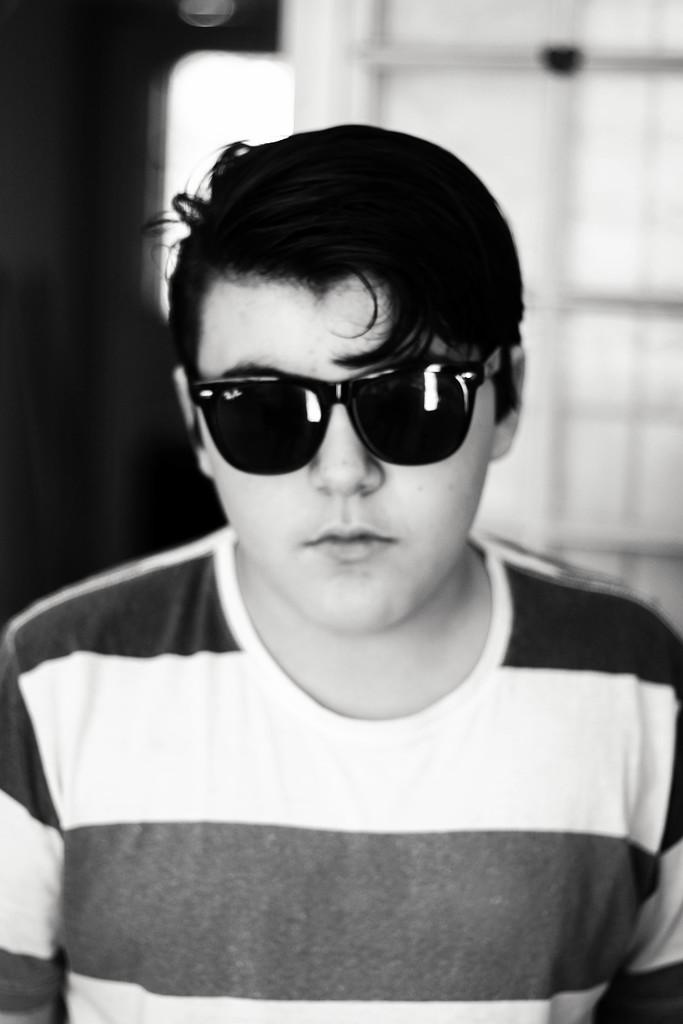What is the color scheme of the image? The image is black and white. Can you describe the person in the image? The person in the image is wearing glasses. What can be seen in the background of the image? There is a wall in the background of the image. What type of bag is the rat carrying in the image? There is no rat or bag present in the image; it features a person wearing glasses in a black and white setting with a wall in the background. 